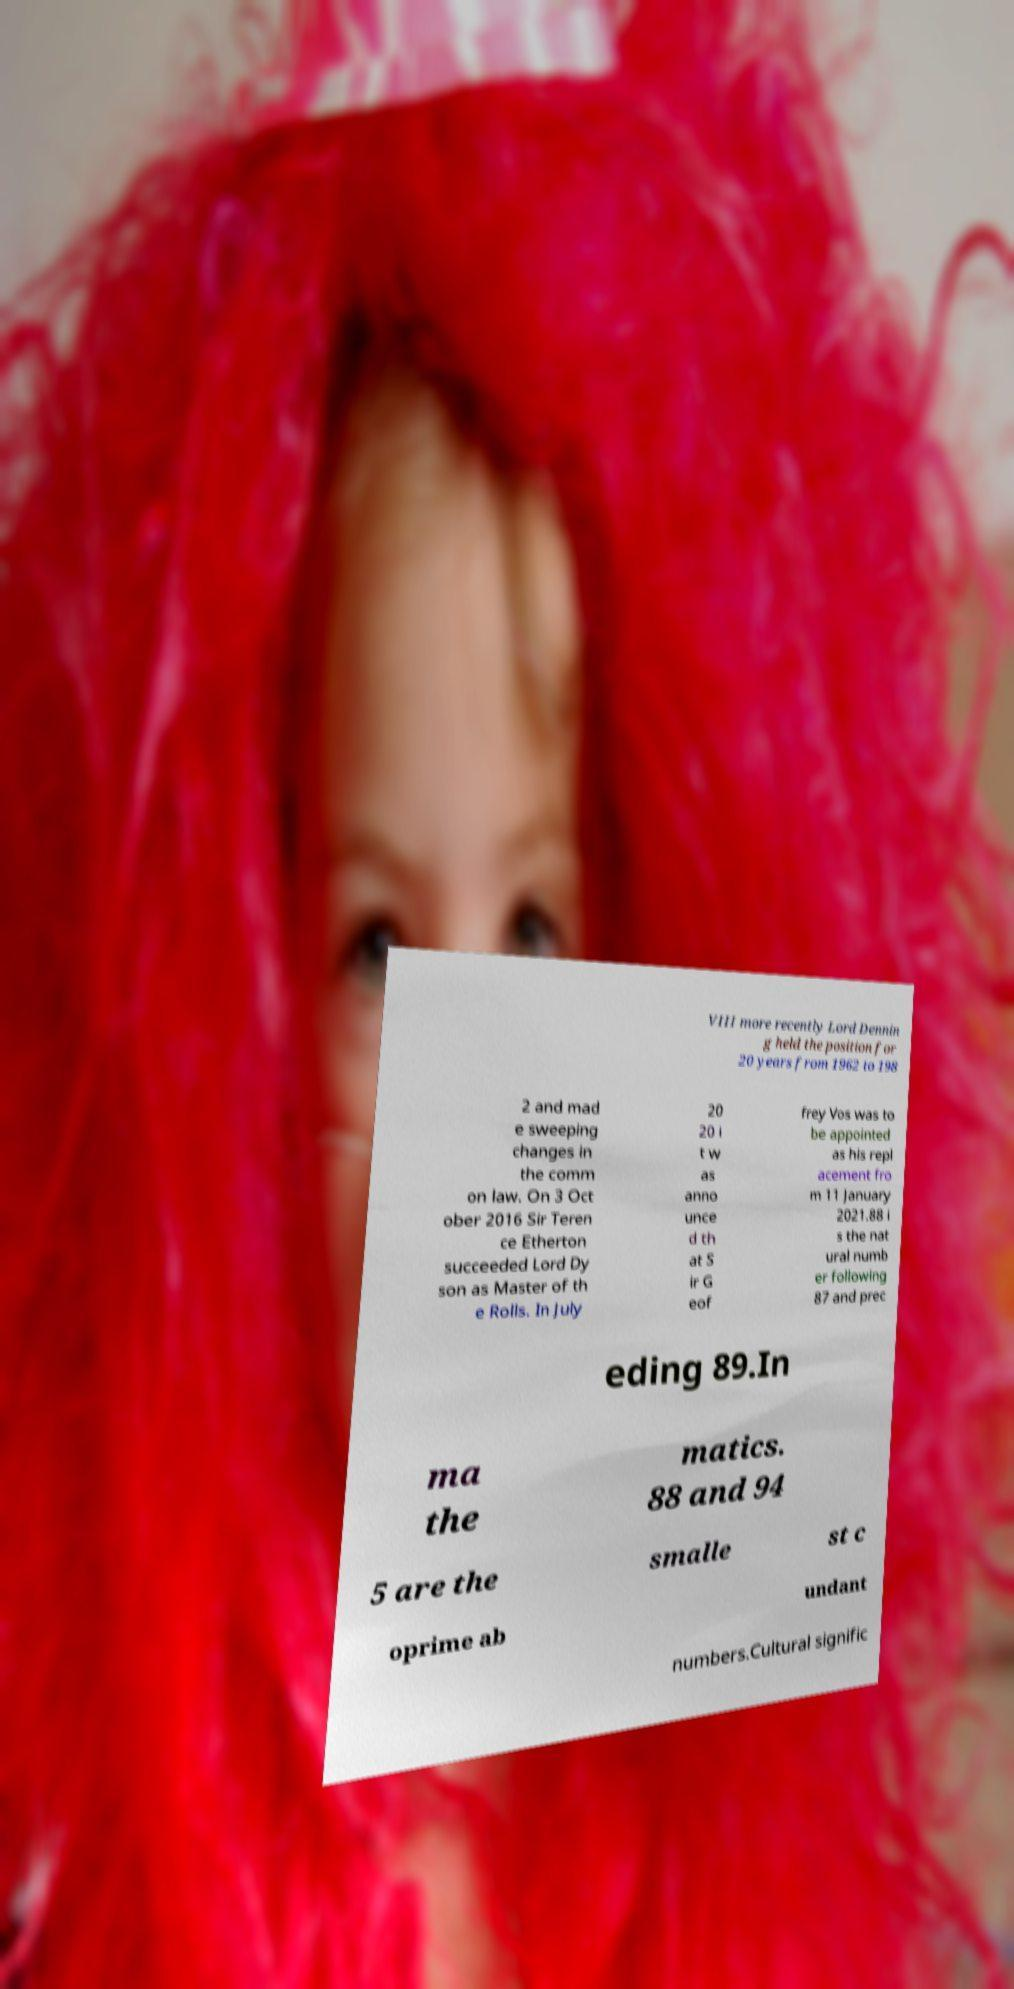Can you accurately transcribe the text from the provided image for me? VIII more recently Lord Dennin g held the position for 20 years from 1962 to 198 2 and mad e sweeping changes in the comm on law. On 3 Oct ober 2016 Sir Teren ce Etherton succeeded Lord Dy son as Master of th e Rolls. In July 20 20 i t w as anno unce d th at S ir G eof frey Vos was to be appointed as his repl acement fro m 11 January 2021.88 i s the nat ural numb er following 87 and prec eding 89.In ma the matics. 88 and 94 5 are the smalle st c oprime ab undant numbers.Cultural signific 